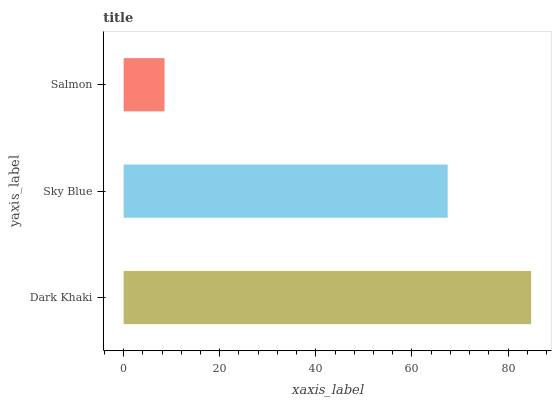Is Salmon the minimum?
Answer yes or no. Yes. Is Dark Khaki the maximum?
Answer yes or no. Yes. Is Sky Blue the minimum?
Answer yes or no. No. Is Sky Blue the maximum?
Answer yes or no. No. Is Dark Khaki greater than Sky Blue?
Answer yes or no. Yes. Is Sky Blue less than Dark Khaki?
Answer yes or no. Yes. Is Sky Blue greater than Dark Khaki?
Answer yes or no. No. Is Dark Khaki less than Sky Blue?
Answer yes or no. No. Is Sky Blue the high median?
Answer yes or no. Yes. Is Sky Blue the low median?
Answer yes or no. Yes. Is Salmon the high median?
Answer yes or no. No. Is Salmon the low median?
Answer yes or no. No. 